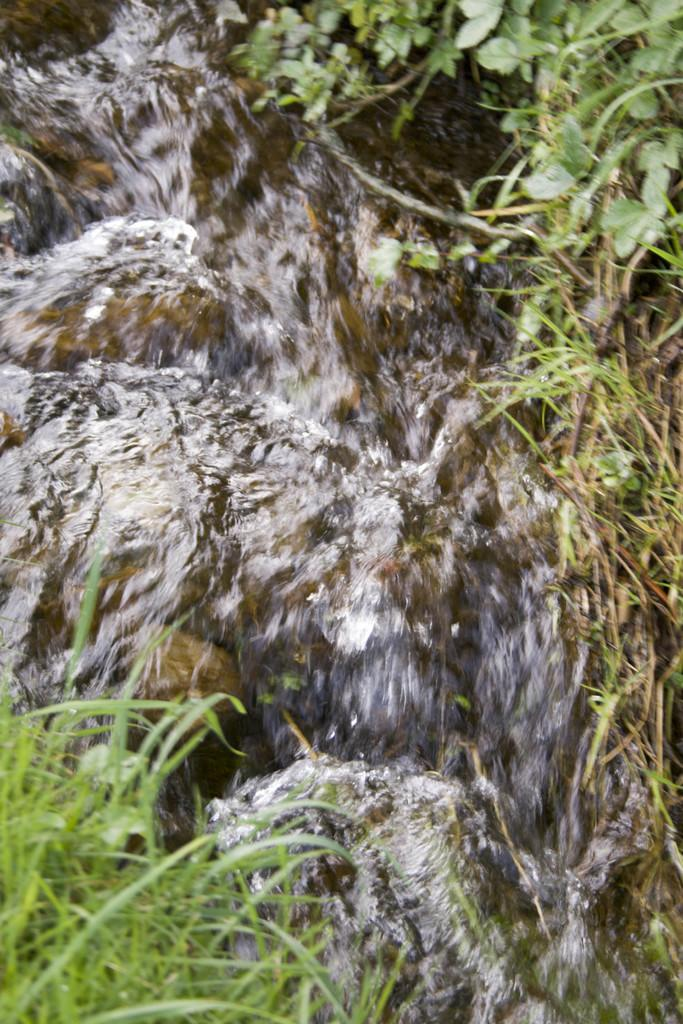What is the main subject of the image? The main subject of the image is water flowing. What can be seen on the ground on either side of the water? There is grass on the ground on either side of the water. What other natural element is visible in the image? Leaves of a plant are visible in the top right of the image. Where is the expert in the image? There is no expert present in the image; it features a natural scene with water, grass, and leaves. How many eggs can be seen in the image? There are no eggs present in the image. 